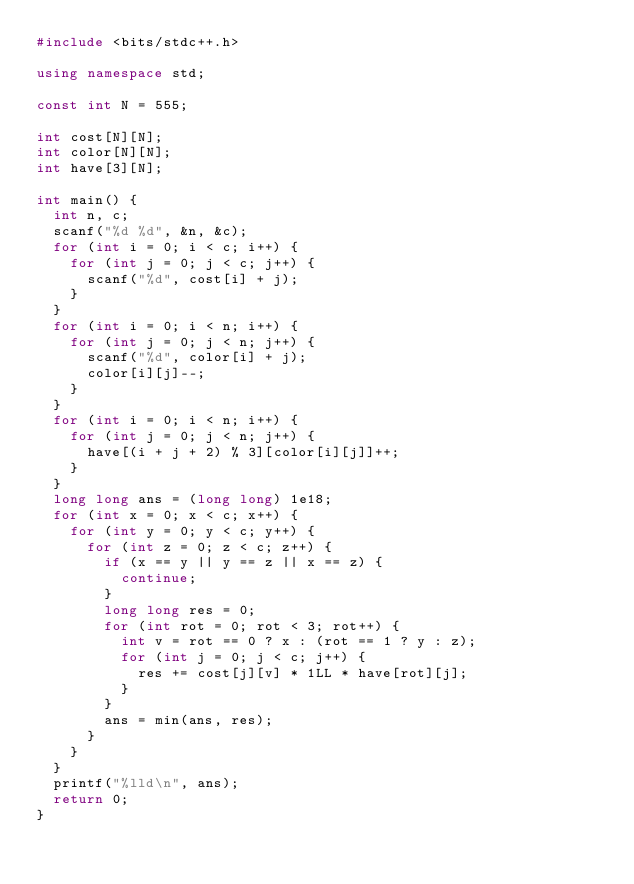<code> <loc_0><loc_0><loc_500><loc_500><_C++_>#include <bits/stdc++.h>

using namespace std;

const int N = 555;

int cost[N][N];
int color[N][N];
int have[3][N];

int main() {
  int n, c;
  scanf("%d %d", &n, &c);
  for (int i = 0; i < c; i++) {
    for (int j = 0; j < c; j++) {
      scanf("%d", cost[i] + j);
    }
  }
  for (int i = 0; i < n; i++) {
    for (int j = 0; j < n; j++) {
      scanf("%d", color[i] + j);
      color[i][j]--;
    }
  }
  for (int i = 0; i < n; i++) {
    for (int j = 0; j < n; j++) {
      have[(i + j + 2) % 3][color[i][j]]++;
    }
  }
  long long ans = (long long) 1e18;
  for (int x = 0; x < c; x++) {
    for (int y = 0; y < c; y++) {
      for (int z = 0; z < c; z++) {
        if (x == y || y == z || x == z) {
          continue;
        }
        long long res = 0;
        for (int rot = 0; rot < 3; rot++) {
          int v = rot == 0 ? x : (rot == 1 ? y : z);
          for (int j = 0; j < c; j++) {
            res += cost[j][v] * 1LL * have[rot][j];
          }
        }
        ans = min(ans, res);
      }
    }
  }
  printf("%lld\n", ans);
  return 0;
}</code> 